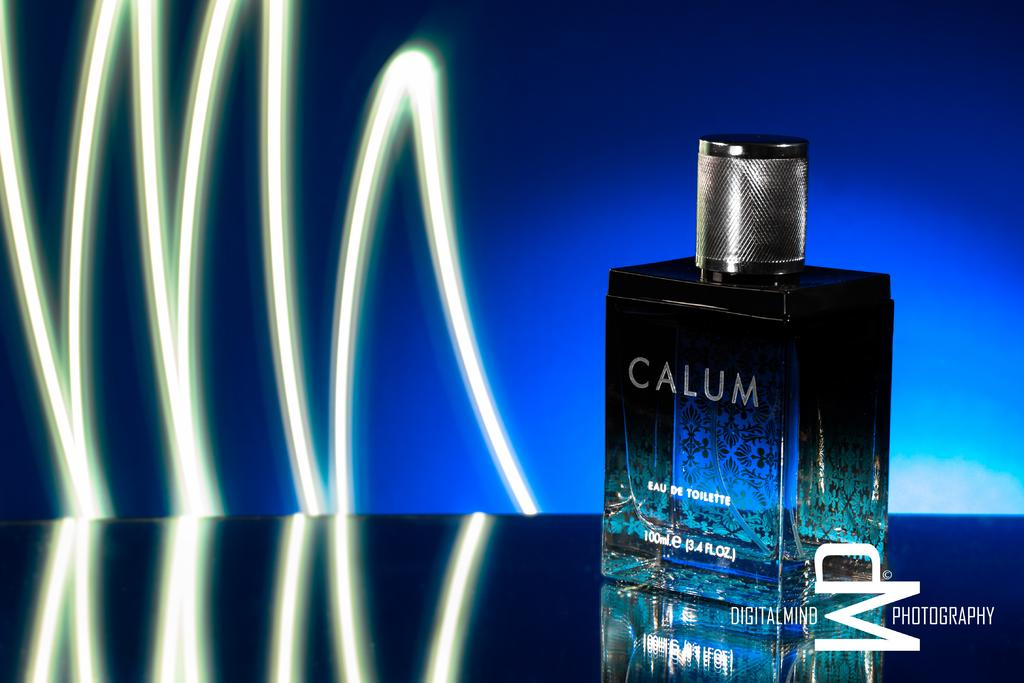Provide a one-sentence caption for the provided image. A square bottle that has the words Calum on it. 